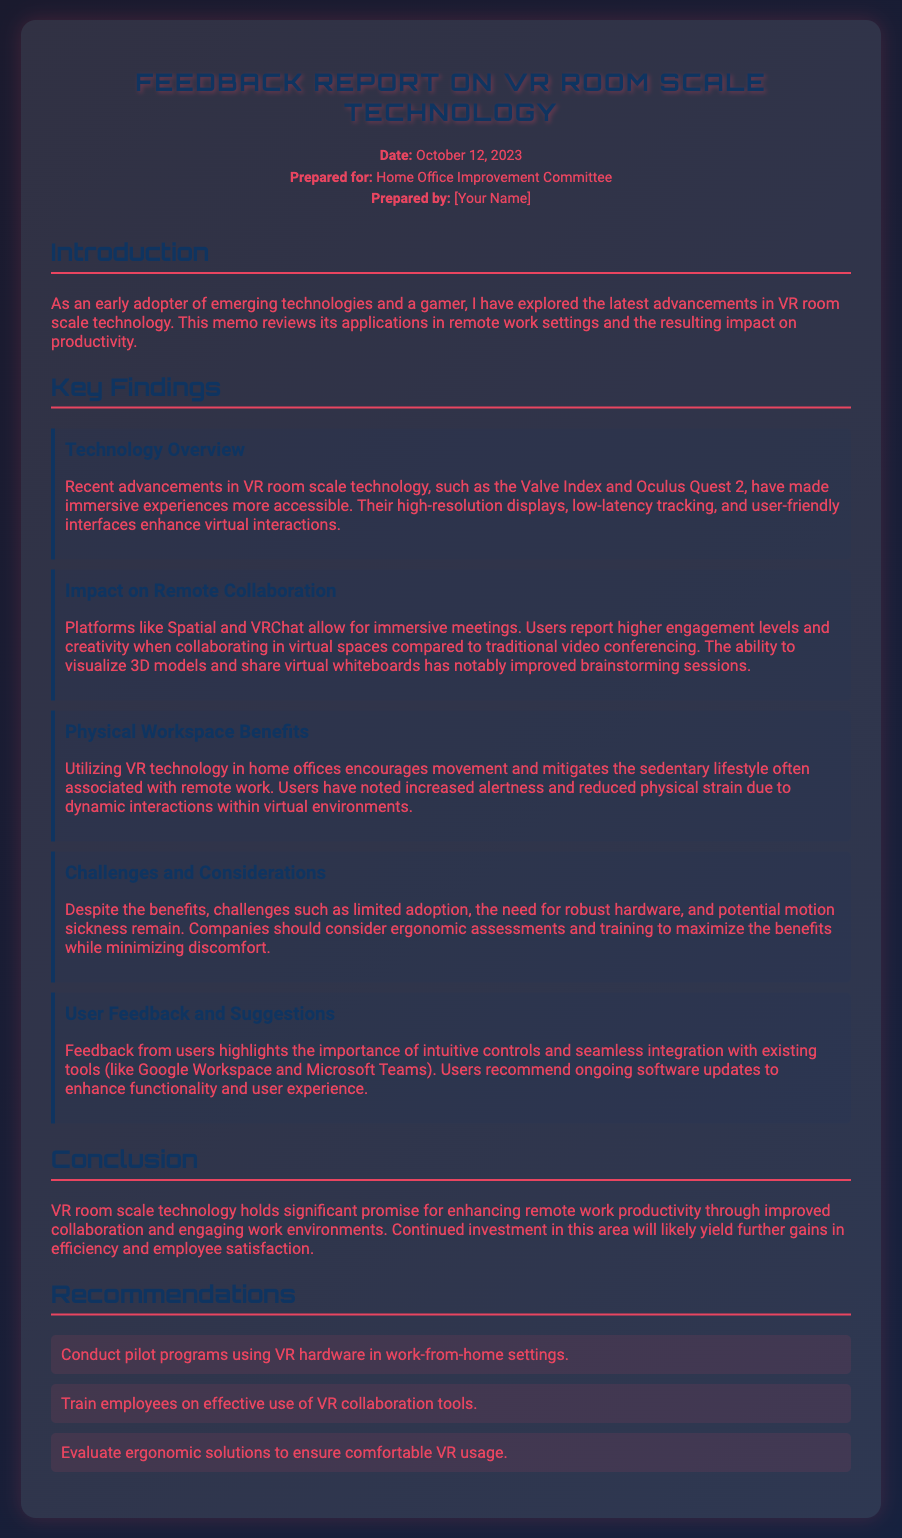What is the date of the memo? The date of the memo is stated in the header section.
Answer: October 12, 2023 Who is the memo prepared for? The memo header specifies the audience for which it was prepared.
Answer: Home Office Improvement Committee What technology is mentioned as an example in the report? The technology section lists specific VR technologies discussed in the memo.
Answer: Valve Index and Oculus Quest 2 What is one major benefit of VR technology in remote work? The document discusses various benefits of VR technology, highlighting one key advantage.
Answer: Increased alertness What is a challenge mentioned in the memo? The challenges section outlines specific difficulties associated with the use of VR technology in remote work.
Answer: Limited adoption What type of document is this? The structure and content indicate its purpose and type of presentation.
Answer: Memo What is one recommendation made in the document? The recommendations section provides actionable suggestions based on the findings.
Answer: Conduct pilot programs using VR hardware What is the primary focus of the report? The introduction clearly outlines the main theme and purpose of the memo.
Answer: VR room scale technology and its impact on remote work productivity 